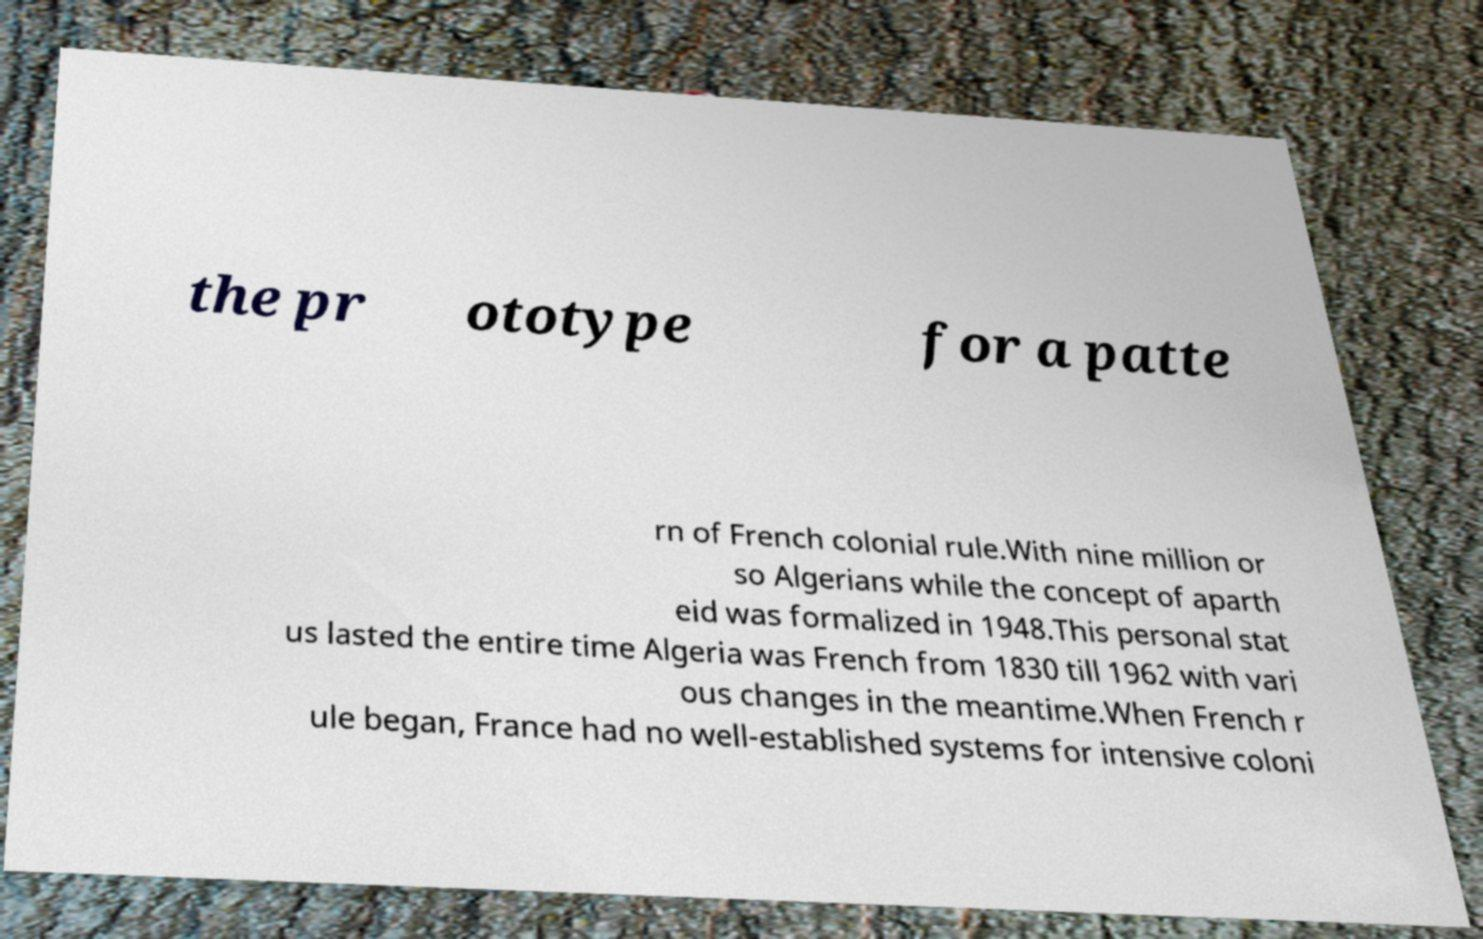Could you assist in decoding the text presented in this image and type it out clearly? the pr ototype for a patte rn of French colonial rule.With nine million or so Algerians while the concept of aparth eid was formalized in 1948.This personal stat us lasted the entire time Algeria was French from 1830 till 1962 with vari ous changes in the meantime.When French r ule began, France had no well-established systems for intensive coloni 